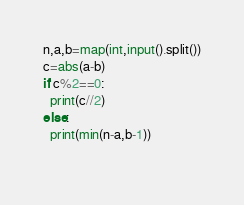<code> <loc_0><loc_0><loc_500><loc_500><_Python_>n,a,b=map(int,input().split())
c=abs(a-b)
if c%2==0:
  print(c//2)
else:
  print(min(n-a,b-1))
  </code> 